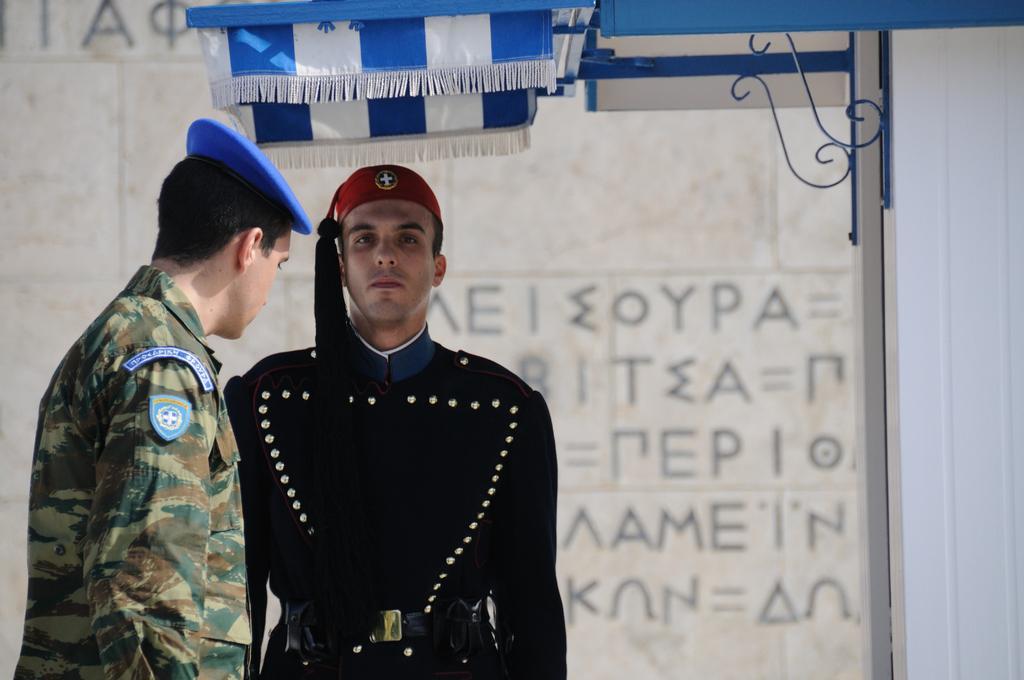Please provide a concise description of this image. In this image in the front there are persons standing. In the background there is a tent which is blue in colour and there is some text written on the wall. 